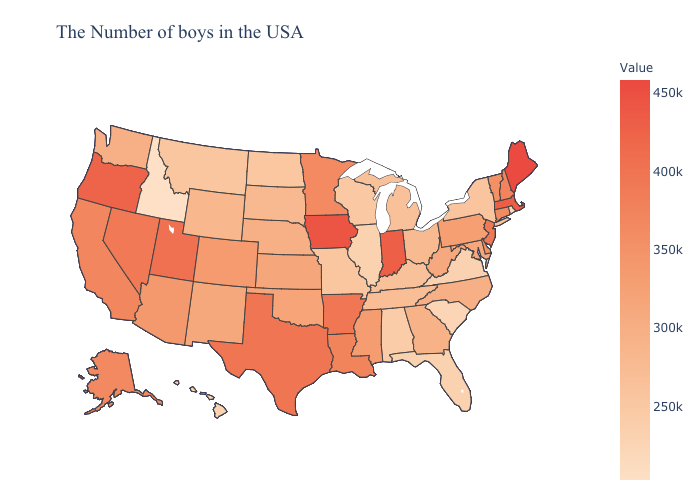Which states have the lowest value in the USA?
Keep it brief. Idaho. Among the states that border Oklahoma , does New Mexico have the highest value?
Concise answer only. No. Does Oklahoma have a lower value than Louisiana?
Answer briefly. Yes. Does Arkansas have the lowest value in the USA?
Concise answer only. No. Is the legend a continuous bar?
Answer briefly. Yes. Does Texas have the highest value in the South?
Give a very brief answer. Yes. Which states hav the highest value in the Northeast?
Give a very brief answer. Maine. 